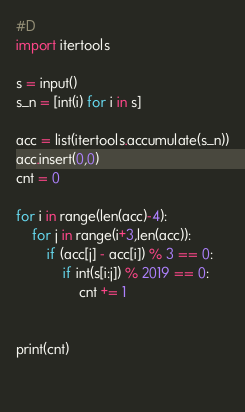<code> <loc_0><loc_0><loc_500><loc_500><_Python_>#D
import itertools

s = input()
s_n = [int(i) for i in s]
        
acc = list(itertools.accumulate(s_n))
acc.insert(0,0)
cnt = 0

for i in range(len(acc)-4):
    for j in range(i+3,len(acc)):
        if (acc[j] - acc[i]) % 3 == 0:
            if int(s[i:j]) % 2019 == 0:
                cnt += 1
                

print(cnt)

            </code> 